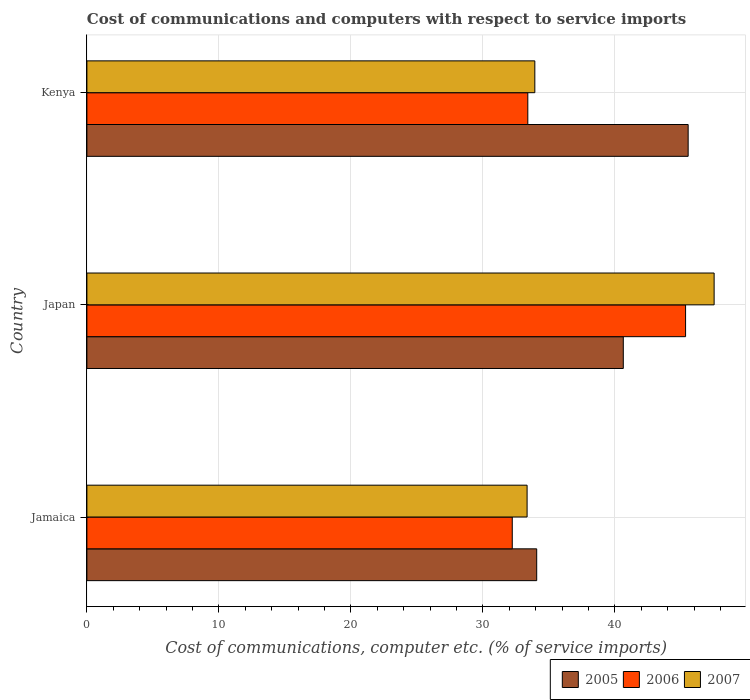Are the number of bars on each tick of the Y-axis equal?
Your answer should be compact. Yes. How many bars are there on the 1st tick from the top?
Your answer should be compact. 3. In how many cases, is the number of bars for a given country not equal to the number of legend labels?
Offer a very short reply. 0. What is the cost of communications and computers in 2007 in Kenya?
Your answer should be compact. 33.93. Across all countries, what is the maximum cost of communications and computers in 2006?
Your answer should be very brief. 45.36. Across all countries, what is the minimum cost of communications and computers in 2005?
Your response must be concise. 34.08. In which country was the cost of communications and computers in 2006 maximum?
Ensure brevity in your answer.  Japan. In which country was the cost of communications and computers in 2006 minimum?
Make the answer very short. Jamaica. What is the total cost of communications and computers in 2005 in the graph?
Your answer should be very brief. 120.27. What is the difference between the cost of communications and computers in 2006 in Japan and that in Kenya?
Keep it short and to the point. 11.95. What is the difference between the cost of communications and computers in 2007 in Kenya and the cost of communications and computers in 2006 in Jamaica?
Provide a succinct answer. 1.71. What is the average cost of communications and computers in 2005 per country?
Give a very brief answer. 40.09. What is the difference between the cost of communications and computers in 2007 and cost of communications and computers in 2005 in Kenya?
Offer a terse response. -11.62. In how many countries, is the cost of communications and computers in 2005 greater than 26 %?
Your answer should be very brief. 3. What is the ratio of the cost of communications and computers in 2007 in Jamaica to that in Japan?
Provide a succinct answer. 0.7. What is the difference between the highest and the second highest cost of communications and computers in 2006?
Provide a succinct answer. 11.95. What is the difference between the highest and the lowest cost of communications and computers in 2005?
Your answer should be compact. 11.47. In how many countries, is the cost of communications and computers in 2007 greater than the average cost of communications and computers in 2007 taken over all countries?
Offer a terse response. 1. Is the sum of the cost of communications and computers in 2006 in Japan and Kenya greater than the maximum cost of communications and computers in 2007 across all countries?
Keep it short and to the point. Yes. Are all the bars in the graph horizontal?
Provide a short and direct response. Yes. Does the graph contain any zero values?
Keep it short and to the point. No. How are the legend labels stacked?
Keep it short and to the point. Horizontal. What is the title of the graph?
Offer a terse response. Cost of communications and computers with respect to service imports. What is the label or title of the X-axis?
Provide a succinct answer. Cost of communications, computer etc. (% of service imports). What is the Cost of communications, computer etc. (% of service imports) of 2005 in Jamaica?
Keep it short and to the point. 34.08. What is the Cost of communications, computer etc. (% of service imports) of 2006 in Jamaica?
Your answer should be compact. 32.23. What is the Cost of communications, computer etc. (% of service imports) in 2007 in Jamaica?
Your answer should be very brief. 33.35. What is the Cost of communications, computer etc. (% of service imports) in 2005 in Japan?
Make the answer very short. 40.64. What is the Cost of communications, computer etc. (% of service imports) in 2006 in Japan?
Provide a short and direct response. 45.36. What is the Cost of communications, computer etc. (% of service imports) of 2007 in Japan?
Ensure brevity in your answer.  47.52. What is the Cost of communications, computer etc. (% of service imports) in 2005 in Kenya?
Offer a terse response. 45.55. What is the Cost of communications, computer etc. (% of service imports) of 2006 in Kenya?
Offer a terse response. 33.4. What is the Cost of communications, computer etc. (% of service imports) of 2007 in Kenya?
Provide a short and direct response. 33.93. Across all countries, what is the maximum Cost of communications, computer etc. (% of service imports) of 2005?
Make the answer very short. 45.55. Across all countries, what is the maximum Cost of communications, computer etc. (% of service imports) of 2006?
Offer a terse response. 45.36. Across all countries, what is the maximum Cost of communications, computer etc. (% of service imports) in 2007?
Provide a short and direct response. 47.52. Across all countries, what is the minimum Cost of communications, computer etc. (% of service imports) of 2005?
Your answer should be compact. 34.08. Across all countries, what is the minimum Cost of communications, computer etc. (% of service imports) of 2006?
Your answer should be very brief. 32.23. Across all countries, what is the minimum Cost of communications, computer etc. (% of service imports) of 2007?
Provide a succinct answer. 33.35. What is the total Cost of communications, computer etc. (% of service imports) in 2005 in the graph?
Your answer should be compact. 120.27. What is the total Cost of communications, computer etc. (% of service imports) of 2006 in the graph?
Provide a short and direct response. 110.98. What is the total Cost of communications, computer etc. (% of service imports) in 2007 in the graph?
Your answer should be very brief. 114.8. What is the difference between the Cost of communications, computer etc. (% of service imports) in 2005 in Jamaica and that in Japan?
Your answer should be compact. -6.56. What is the difference between the Cost of communications, computer etc. (% of service imports) of 2006 in Jamaica and that in Japan?
Offer a terse response. -13.13. What is the difference between the Cost of communications, computer etc. (% of service imports) of 2007 in Jamaica and that in Japan?
Your response must be concise. -14.17. What is the difference between the Cost of communications, computer etc. (% of service imports) of 2005 in Jamaica and that in Kenya?
Ensure brevity in your answer.  -11.47. What is the difference between the Cost of communications, computer etc. (% of service imports) in 2006 in Jamaica and that in Kenya?
Keep it short and to the point. -1.18. What is the difference between the Cost of communications, computer etc. (% of service imports) in 2007 in Jamaica and that in Kenya?
Give a very brief answer. -0.59. What is the difference between the Cost of communications, computer etc. (% of service imports) of 2005 in Japan and that in Kenya?
Your answer should be compact. -4.91. What is the difference between the Cost of communications, computer etc. (% of service imports) in 2006 in Japan and that in Kenya?
Provide a succinct answer. 11.95. What is the difference between the Cost of communications, computer etc. (% of service imports) of 2007 in Japan and that in Kenya?
Ensure brevity in your answer.  13.58. What is the difference between the Cost of communications, computer etc. (% of service imports) of 2005 in Jamaica and the Cost of communications, computer etc. (% of service imports) of 2006 in Japan?
Provide a short and direct response. -11.28. What is the difference between the Cost of communications, computer etc. (% of service imports) in 2005 in Jamaica and the Cost of communications, computer etc. (% of service imports) in 2007 in Japan?
Offer a very short reply. -13.44. What is the difference between the Cost of communications, computer etc. (% of service imports) of 2006 in Jamaica and the Cost of communications, computer etc. (% of service imports) of 2007 in Japan?
Ensure brevity in your answer.  -15.29. What is the difference between the Cost of communications, computer etc. (% of service imports) in 2005 in Jamaica and the Cost of communications, computer etc. (% of service imports) in 2006 in Kenya?
Your response must be concise. 0.67. What is the difference between the Cost of communications, computer etc. (% of service imports) of 2005 in Jamaica and the Cost of communications, computer etc. (% of service imports) of 2007 in Kenya?
Make the answer very short. 0.14. What is the difference between the Cost of communications, computer etc. (% of service imports) of 2006 in Jamaica and the Cost of communications, computer etc. (% of service imports) of 2007 in Kenya?
Your answer should be very brief. -1.71. What is the difference between the Cost of communications, computer etc. (% of service imports) of 2005 in Japan and the Cost of communications, computer etc. (% of service imports) of 2006 in Kenya?
Give a very brief answer. 7.23. What is the difference between the Cost of communications, computer etc. (% of service imports) in 2005 in Japan and the Cost of communications, computer etc. (% of service imports) in 2007 in Kenya?
Your answer should be very brief. 6.7. What is the difference between the Cost of communications, computer etc. (% of service imports) in 2006 in Japan and the Cost of communications, computer etc. (% of service imports) in 2007 in Kenya?
Provide a succinct answer. 11.42. What is the average Cost of communications, computer etc. (% of service imports) of 2005 per country?
Your answer should be compact. 40.09. What is the average Cost of communications, computer etc. (% of service imports) of 2006 per country?
Make the answer very short. 36.99. What is the average Cost of communications, computer etc. (% of service imports) of 2007 per country?
Your answer should be very brief. 38.27. What is the difference between the Cost of communications, computer etc. (% of service imports) of 2005 and Cost of communications, computer etc. (% of service imports) of 2006 in Jamaica?
Offer a terse response. 1.85. What is the difference between the Cost of communications, computer etc. (% of service imports) of 2005 and Cost of communications, computer etc. (% of service imports) of 2007 in Jamaica?
Make the answer very short. 0.73. What is the difference between the Cost of communications, computer etc. (% of service imports) in 2006 and Cost of communications, computer etc. (% of service imports) in 2007 in Jamaica?
Your answer should be very brief. -1.12. What is the difference between the Cost of communications, computer etc. (% of service imports) in 2005 and Cost of communications, computer etc. (% of service imports) in 2006 in Japan?
Ensure brevity in your answer.  -4.72. What is the difference between the Cost of communications, computer etc. (% of service imports) in 2005 and Cost of communications, computer etc. (% of service imports) in 2007 in Japan?
Your answer should be compact. -6.88. What is the difference between the Cost of communications, computer etc. (% of service imports) in 2006 and Cost of communications, computer etc. (% of service imports) in 2007 in Japan?
Keep it short and to the point. -2.16. What is the difference between the Cost of communications, computer etc. (% of service imports) in 2005 and Cost of communications, computer etc. (% of service imports) in 2006 in Kenya?
Your response must be concise. 12.15. What is the difference between the Cost of communications, computer etc. (% of service imports) in 2005 and Cost of communications, computer etc. (% of service imports) in 2007 in Kenya?
Make the answer very short. 11.62. What is the difference between the Cost of communications, computer etc. (% of service imports) of 2006 and Cost of communications, computer etc. (% of service imports) of 2007 in Kenya?
Offer a very short reply. -0.53. What is the ratio of the Cost of communications, computer etc. (% of service imports) of 2005 in Jamaica to that in Japan?
Your response must be concise. 0.84. What is the ratio of the Cost of communications, computer etc. (% of service imports) of 2006 in Jamaica to that in Japan?
Your answer should be compact. 0.71. What is the ratio of the Cost of communications, computer etc. (% of service imports) of 2007 in Jamaica to that in Japan?
Provide a succinct answer. 0.7. What is the ratio of the Cost of communications, computer etc. (% of service imports) of 2005 in Jamaica to that in Kenya?
Your answer should be compact. 0.75. What is the ratio of the Cost of communications, computer etc. (% of service imports) of 2006 in Jamaica to that in Kenya?
Your response must be concise. 0.96. What is the ratio of the Cost of communications, computer etc. (% of service imports) in 2007 in Jamaica to that in Kenya?
Your answer should be compact. 0.98. What is the ratio of the Cost of communications, computer etc. (% of service imports) in 2005 in Japan to that in Kenya?
Provide a short and direct response. 0.89. What is the ratio of the Cost of communications, computer etc. (% of service imports) of 2006 in Japan to that in Kenya?
Give a very brief answer. 1.36. What is the ratio of the Cost of communications, computer etc. (% of service imports) in 2007 in Japan to that in Kenya?
Your answer should be very brief. 1.4. What is the difference between the highest and the second highest Cost of communications, computer etc. (% of service imports) of 2005?
Give a very brief answer. 4.91. What is the difference between the highest and the second highest Cost of communications, computer etc. (% of service imports) of 2006?
Offer a very short reply. 11.95. What is the difference between the highest and the second highest Cost of communications, computer etc. (% of service imports) in 2007?
Your answer should be very brief. 13.58. What is the difference between the highest and the lowest Cost of communications, computer etc. (% of service imports) of 2005?
Provide a short and direct response. 11.47. What is the difference between the highest and the lowest Cost of communications, computer etc. (% of service imports) of 2006?
Your answer should be very brief. 13.13. What is the difference between the highest and the lowest Cost of communications, computer etc. (% of service imports) of 2007?
Ensure brevity in your answer.  14.17. 